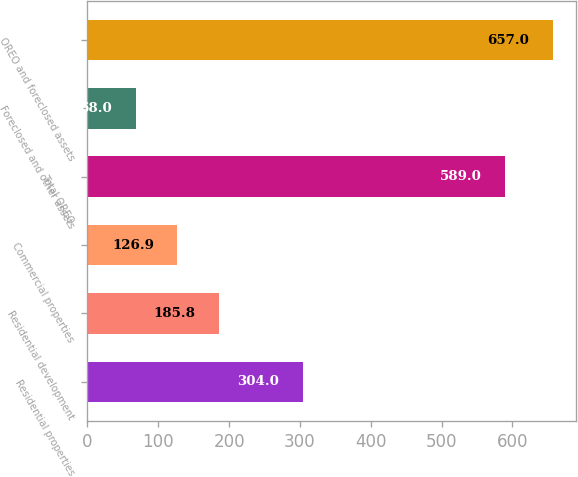<chart> <loc_0><loc_0><loc_500><loc_500><bar_chart><fcel>Residential properties<fcel>Residential development<fcel>Commercial properties<fcel>Total OREO<fcel>Foreclosed and other assets<fcel>OREO and foreclosed assets<nl><fcel>304<fcel>185.8<fcel>126.9<fcel>589<fcel>68<fcel>657<nl></chart> 